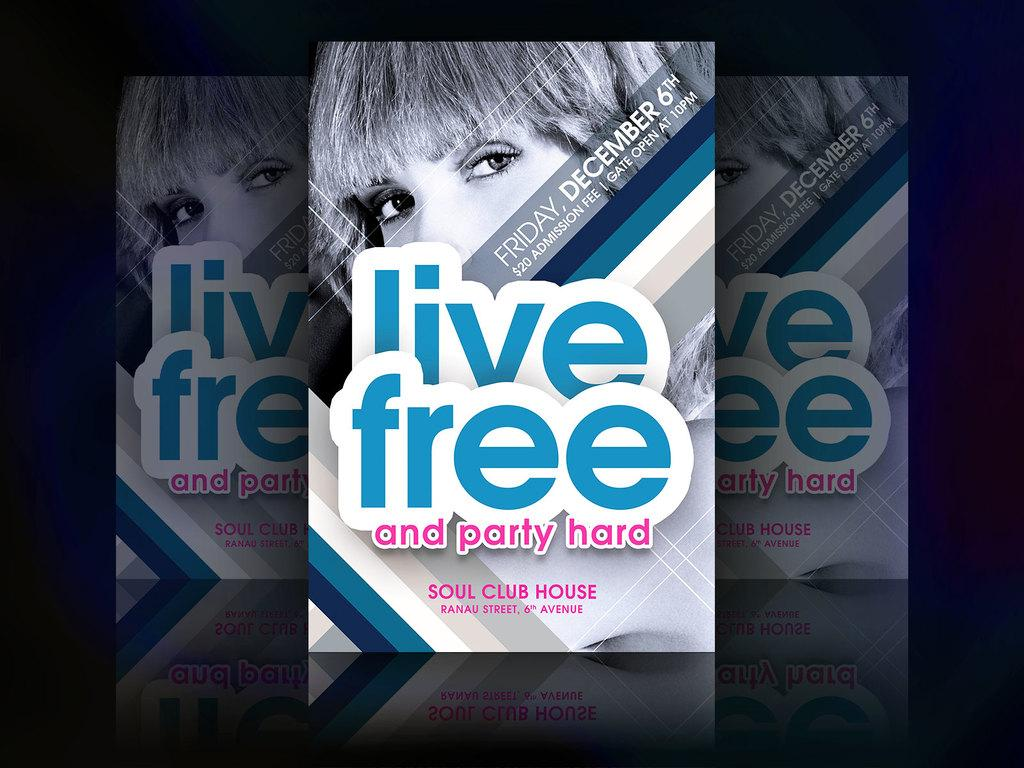<image>
Share a concise interpretation of the image provided. A poster for a live free event at the Soul Club House. 